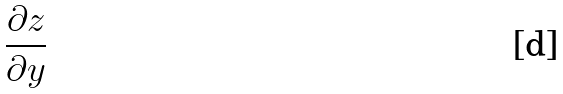<formula> <loc_0><loc_0><loc_500><loc_500>\frac { \partial z } { \partial y }</formula> 